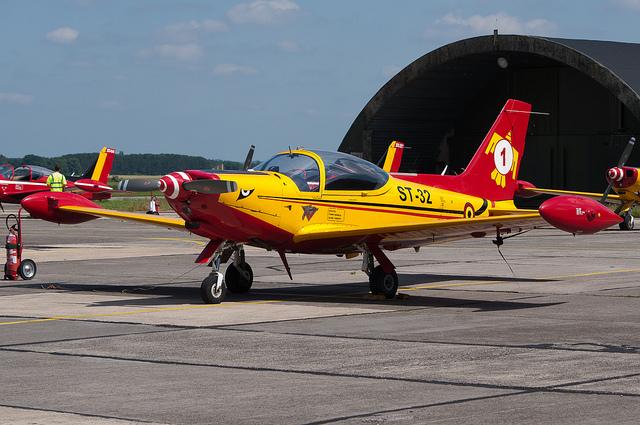What color is the plane?
Answer briefly. Yellow and red. What colors is this small plane?
Give a very brief answer. Red and yellow. Is the plane in the air?
Short answer required. No. 